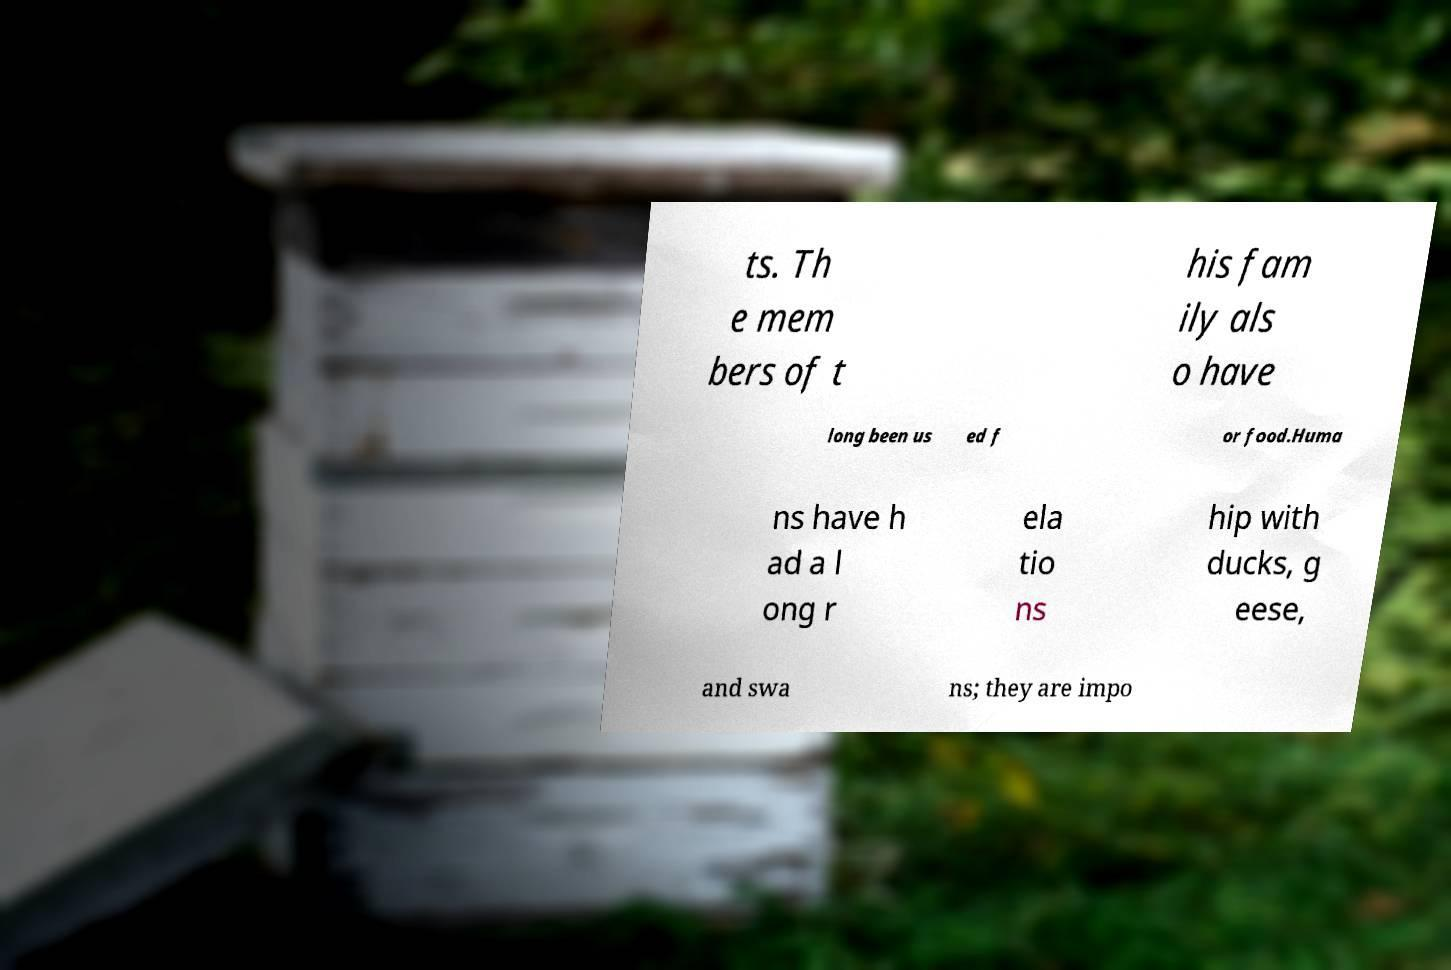Please read and relay the text visible in this image. What does it say? ts. Th e mem bers of t his fam ily als o have long been us ed f or food.Huma ns have h ad a l ong r ela tio ns hip with ducks, g eese, and swa ns; they are impo 